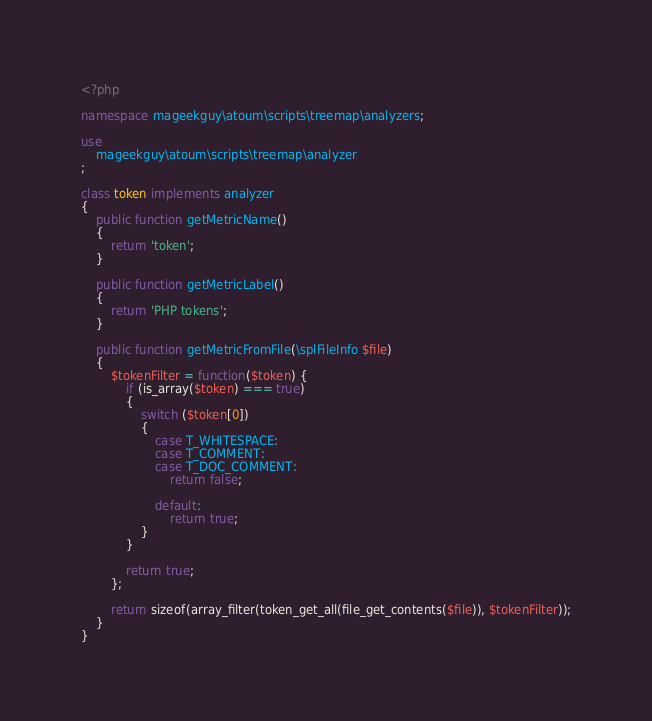Convert code to text. <code><loc_0><loc_0><loc_500><loc_500><_PHP_><?php

namespace mageekguy\atoum\scripts\treemap\analyzers;

use
	mageekguy\atoum\scripts\treemap\analyzer
;

class token implements analyzer
{
	public function getMetricName()
	{
		return 'token';
	}

	public function getMetricLabel()
	{
		return 'PHP tokens';
	}

	public function getMetricFromFile(\splFileInfo $file)
	{
		$tokenFilter = function($token) {
			if (is_array($token) === true)
			{
				switch ($token[0])
				{
					case T_WHITESPACE:
					case T_COMMENT:
					case T_DOC_COMMENT:
						return false;

					default:
						return true;
				}
			}

			return true;
		};

		return sizeof(array_filter(token_get_all(file_get_contents($file)), $tokenFilter));
	}
}
</code> 